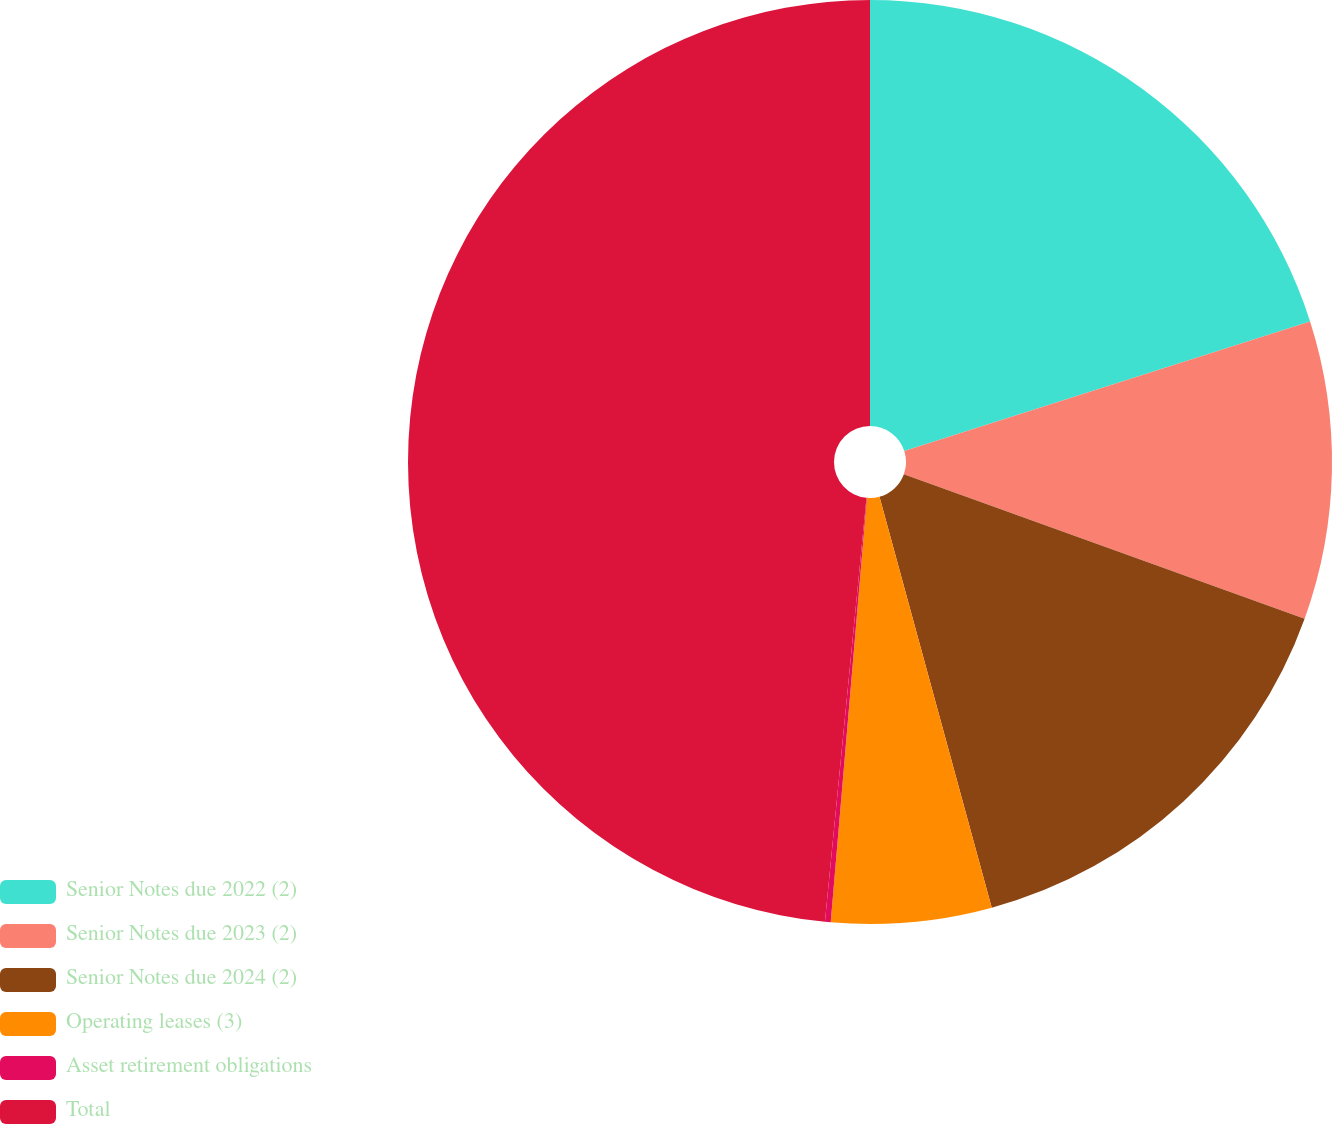Convert chart. <chart><loc_0><loc_0><loc_500><loc_500><pie_chart><fcel>Senior Notes due 2022 (2)<fcel>Senior Notes due 2023 (2)<fcel>Senior Notes due 2024 (2)<fcel>Operating leases (3)<fcel>Asset retirement obligations<fcel>Total<nl><fcel>20.08%<fcel>10.43%<fcel>15.25%<fcel>5.6%<fcel>0.2%<fcel>48.45%<nl></chart> 